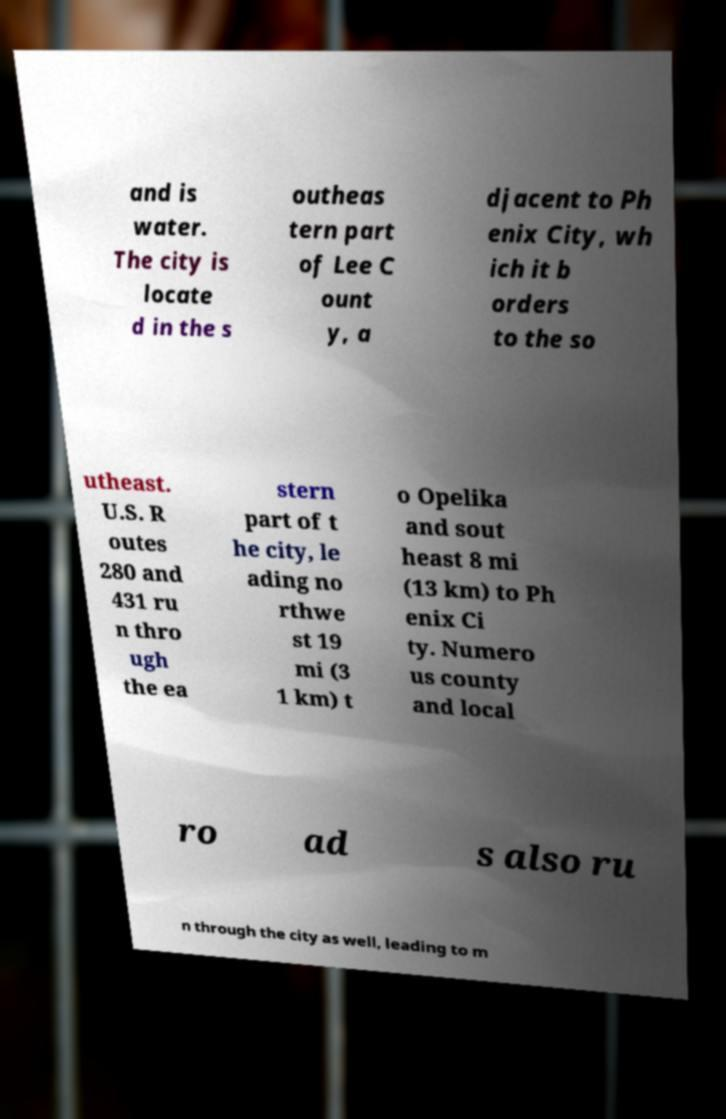Could you extract and type out the text from this image? and is water. The city is locate d in the s outheas tern part of Lee C ount y, a djacent to Ph enix City, wh ich it b orders to the so utheast. U.S. R outes 280 and 431 ru n thro ugh the ea stern part of t he city, le ading no rthwe st 19 mi (3 1 km) t o Opelika and sout heast 8 mi (13 km) to Ph enix Ci ty. Numero us county and local ro ad s also ru n through the city as well, leading to m 